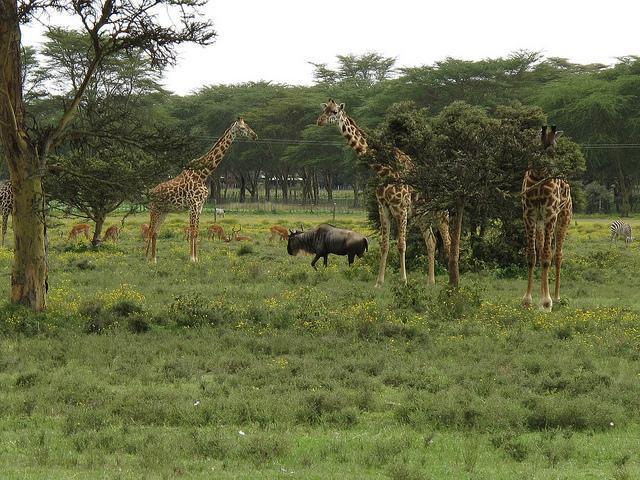How many distinct species of animals are in the field?
Choose the right answer and clarify with the format: 'Answer: answer
Rationale: rationale.'
Options: Two, four, three, five. Answer: four.
Rationale: There are giraffes, deer, a pig and some kind of other animal. 